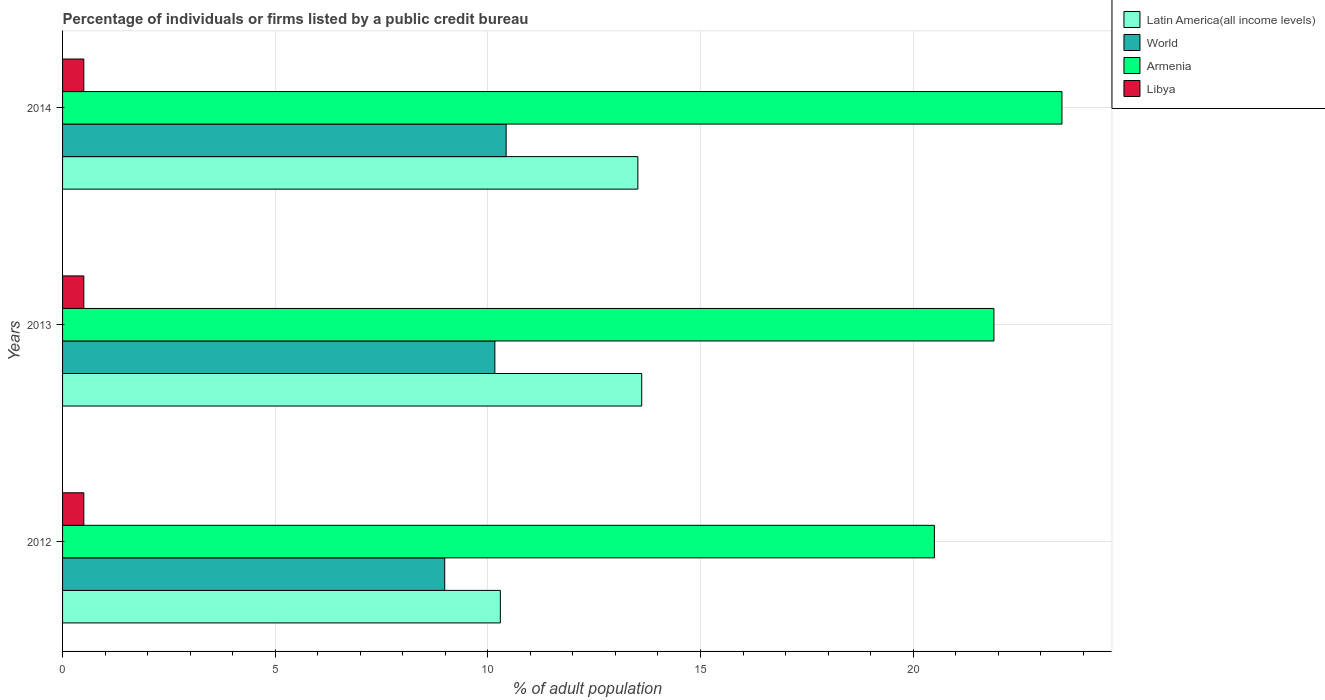How many different coloured bars are there?
Your answer should be compact. 4. Are the number of bars per tick equal to the number of legend labels?
Your answer should be compact. Yes. How many bars are there on the 2nd tick from the top?
Offer a terse response. 4. How many bars are there on the 3rd tick from the bottom?
Make the answer very short. 4. In how many cases, is the number of bars for a given year not equal to the number of legend labels?
Your answer should be very brief. 0. What is the percentage of population listed by a public credit bureau in World in 2014?
Keep it short and to the point. 10.43. Across all years, what is the maximum percentage of population listed by a public credit bureau in Latin America(all income levels)?
Make the answer very short. 13.62. Across all years, what is the minimum percentage of population listed by a public credit bureau in Libya?
Keep it short and to the point. 0.5. What is the total percentage of population listed by a public credit bureau in World in the graph?
Ensure brevity in your answer.  29.58. What is the difference between the percentage of population listed by a public credit bureau in Armenia in 2012 and that in 2013?
Make the answer very short. -1.4. What is the difference between the percentage of population listed by a public credit bureau in Armenia in 2013 and the percentage of population listed by a public credit bureau in Libya in 2012?
Give a very brief answer. 21.4. What is the average percentage of population listed by a public credit bureau in World per year?
Offer a very short reply. 9.86. In the year 2014, what is the difference between the percentage of population listed by a public credit bureau in Libya and percentage of population listed by a public credit bureau in Latin America(all income levels)?
Give a very brief answer. -13.03. What is the ratio of the percentage of population listed by a public credit bureau in Armenia in 2012 to that in 2014?
Ensure brevity in your answer.  0.87. What is the difference between the highest and the second highest percentage of population listed by a public credit bureau in Latin America(all income levels)?
Provide a short and direct response. 0.09. What is the difference between the highest and the lowest percentage of population listed by a public credit bureau in Armenia?
Make the answer very short. 3. Is the sum of the percentage of population listed by a public credit bureau in Libya in 2012 and 2014 greater than the maximum percentage of population listed by a public credit bureau in Latin America(all income levels) across all years?
Provide a short and direct response. No. Is it the case that in every year, the sum of the percentage of population listed by a public credit bureau in Latin America(all income levels) and percentage of population listed by a public credit bureau in World is greater than the sum of percentage of population listed by a public credit bureau in Libya and percentage of population listed by a public credit bureau in Armenia?
Make the answer very short. No. What does the 4th bar from the top in 2014 represents?
Make the answer very short. Latin America(all income levels). What does the 1st bar from the bottom in 2012 represents?
Make the answer very short. Latin America(all income levels). How many bars are there?
Your answer should be very brief. 12. How many years are there in the graph?
Make the answer very short. 3. What is the difference between two consecutive major ticks on the X-axis?
Ensure brevity in your answer.  5. Does the graph contain grids?
Provide a short and direct response. Yes. What is the title of the graph?
Offer a terse response. Percentage of individuals or firms listed by a public credit bureau. Does "Sao Tome and Principe" appear as one of the legend labels in the graph?
Your answer should be compact. No. What is the label or title of the X-axis?
Provide a succinct answer. % of adult population. What is the % of adult population of Latin America(all income levels) in 2012?
Keep it short and to the point. 10.29. What is the % of adult population of World in 2012?
Keep it short and to the point. 8.99. What is the % of adult population of Armenia in 2012?
Your response must be concise. 20.5. What is the % of adult population of Libya in 2012?
Ensure brevity in your answer.  0.5. What is the % of adult population in Latin America(all income levels) in 2013?
Offer a terse response. 13.62. What is the % of adult population in World in 2013?
Ensure brevity in your answer.  10.17. What is the % of adult population in Armenia in 2013?
Your answer should be very brief. 21.9. What is the % of adult population of Latin America(all income levels) in 2014?
Keep it short and to the point. 13.53. What is the % of adult population in World in 2014?
Offer a terse response. 10.43. What is the % of adult population in Armenia in 2014?
Your answer should be very brief. 23.5. Across all years, what is the maximum % of adult population in Latin America(all income levels)?
Ensure brevity in your answer.  13.62. Across all years, what is the maximum % of adult population in World?
Offer a terse response. 10.43. Across all years, what is the maximum % of adult population of Armenia?
Give a very brief answer. 23.5. Across all years, what is the minimum % of adult population in Latin America(all income levels)?
Provide a succinct answer. 10.29. Across all years, what is the minimum % of adult population in World?
Offer a terse response. 8.99. What is the total % of adult population of Latin America(all income levels) in the graph?
Ensure brevity in your answer.  37.44. What is the total % of adult population of World in the graph?
Give a very brief answer. 29.58. What is the total % of adult population in Armenia in the graph?
Offer a very short reply. 65.9. What is the difference between the % of adult population of Latin America(all income levels) in 2012 and that in 2013?
Give a very brief answer. -3.32. What is the difference between the % of adult population of World in 2012 and that in 2013?
Provide a succinct answer. -1.18. What is the difference between the % of adult population of Armenia in 2012 and that in 2013?
Your answer should be compact. -1.4. What is the difference between the % of adult population of Latin America(all income levels) in 2012 and that in 2014?
Make the answer very short. -3.23. What is the difference between the % of adult population in World in 2012 and that in 2014?
Give a very brief answer. -1.44. What is the difference between the % of adult population in Latin America(all income levels) in 2013 and that in 2014?
Provide a short and direct response. 0.09. What is the difference between the % of adult population of World in 2013 and that in 2014?
Your answer should be compact. -0.27. What is the difference between the % of adult population of Latin America(all income levels) in 2012 and the % of adult population of World in 2013?
Your answer should be very brief. 0.13. What is the difference between the % of adult population in Latin America(all income levels) in 2012 and the % of adult population in Armenia in 2013?
Your response must be concise. -11.61. What is the difference between the % of adult population in Latin America(all income levels) in 2012 and the % of adult population in Libya in 2013?
Keep it short and to the point. 9.79. What is the difference between the % of adult population in World in 2012 and the % of adult population in Armenia in 2013?
Ensure brevity in your answer.  -12.91. What is the difference between the % of adult population of World in 2012 and the % of adult population of Libya in 2013?
Provide a short and direct response. 8.49. What is the difference between the % of adult population in Armenia in 2012 and the % of adult population in Libya in 2013?
Your answer should be compact. 20. What is the difference between the % of adult population in Latin America(all income levels) in 2012 and the % of adult population in World in 2014?
Provide a short and direct response. -0.14. What is the difference between the % of adult population in Latin America(all income levels) in 2012 and the % of adult population in Armenia in 2014?
Your response must be concise. -13.21. What is the difference between the % of adult population of Latin America(all income levels) in 2012 and the % of adult population of Libya in 2014?
Offer a terse response. 9.79. What is the difference between the % of adult population in World in 2012 and the % of adult population in Armenia in 2014?
Give a very brief answer. -14.51. What is the difference between the % of adult population in World in 2012 and the % of adult population in Libya in 2014?
Your response must be concise. 8.49. What is the difference between the % of adult population in Armenia in 2012 and the % of adult population in Libya in 2014?
Provide a short and direct response. 20. What is the difference between the % of adult population in Latin America(all income levels) in 2013 and the % of adult population in World in 2014?
Provide a succinct answer. 3.19. What is the difference between the % of adult population in Latin America(all income levels) in 2013 and the % of adult population in Armenia in 2014?
Your answer should be compact. -9.88. What is the difference between the % of adult population of Latin America(all income levels) in 2013 and the % of adult population of Libya in 2014?
Ensure brevity in your answer.  13.12. What is the difference between the % of adult population of World in 2013 and the % of adult population of Armenia in 2014?
Keep it short and to the point. -13.33. What is the difference between the % of adult population in World in 2013 and the % of adult population in Libya in 2014?
Ensure brevity in your answer.  9.67. What is the difference between the % of adult population of Armenia in 2013 and the % of adult population of Libya in 2014?
Your answer should be compact. 21.4. What is the average % of adult population in Latin America(all income levels) per year?
Ensure brevity in your answer.  12.48. What is the average % of adult population of World per year?
Offer a very short reply. 9.86. What is the average % of adult population of Armenia per year?
Provide a short and direct response. 21.97. What is the average % of adult population in Libya per year?
Your response must be concise. 0.5. In the year 2012, what is the difference between the % of adult population of Latin America(all income levels) and % of adult population of World?
Ensure brevity in your answer.  1.31. In the year 2012, what is the difference between the % of adult population of Latin America(all income levels) and % of adult population of Armenia?
Keep it short and to the point. -10.21. In the year 2012, what is the difference between the % of adult population in Latin America(all income levels) and % of adult population in Libya?
Provide a short and direct response. 9.79. In the year 2012, what is the difference between the % of adult population in World and % of adult population in Armenia?
Provide a succinct answer. -11.51. In the year 2012, what is the difference between the % of adult population in World and % of adult population in Libya?
Your answer should be very brief. 8.49. In the year 2012, what is the difference between the % of adult population of Armenia and % of adult population of Libya?
Give a very brief answer. 20. In the year 2013, what is the difference between the % of adult population in Latin America(all income levels) and % of adult population in World?
Provide a succinct answer. 3.45. In the year 2013, what is the difference between the % of adult population of Latin America(all income levels) and % of adult population of Armenia?
Your answer should be compact. -8.28. In the year 2013, what is the difference between the % of adult population of Latin America(all income levels) and % of adult population of Libya?
Provide a succinct answer. 13.12. In the year 2013, what is the difference between the % of adult population in World and % of adult population in Armenia?
Make the answer very short. -11.73. In the year 2013, what is the difference between the % of adult population in World and % of adult population in Libya?
Provide a short and direct response. 9.67. In the year 2013, what is the difference between the % of adult population in Armenia and % of adult population in Libya?
Offer a very short reply. 21.4. In the year 2014, what is the difference between the % of adult population in Latin America(all income levels) and % of adult population in World?
Ensure brevity in your answer.  3.1. In the year 2014, what is the difference between the % of adult population in Latin America(all income levels) and % of adult population in Armenia?
Ensure brevity in your answer.  -9.97. In the year 2014, what is the difference between the % of adult population of Latin America(all income levels) and % of adult population of Libya?
Give a very brief answer. 13.03. In the year 2014, what is the difference between the % of adult population of World and % of adult population of Armenia?
Your answer should be very brief. -13.07. In the year 2014, what is the difference between the % of adult population in World and % of adult population in Libya?
Offer a very short reply. 9.93. In the year 2014, what is the difference between the % of adult population in Armenia and % of adult population in Libya?
Make the answer very short. 23. What is the ratio of the % of adult population of Latin America(all income levels) in 2012 to that in 2013?
Give a very brief answer. 0.76. What is the ratio of the % of adult population in World in 2012 to that in 2013?
Your answer should be very brief. 0.88. What is the ratio of the % of adult population in Armenia in 2012 to that in 2013?
Make the answer very short. 0.94. What is the ratio of the % of adult population in Libya in 2012 to that in 2013?
Provide a short and direct response. 1. What is the ratio of the % of adult population in Latin America(all income levels) in 2012 to that in 2014?
Ensure brevity in your answer.  0.76. What is the ratio of the % of adult population in World in 2012 to that in 2014?
Your response must be concise. 0.86. What is the ratio of the % of adult population of Armenia in 2012 to that in 2014?
Give a very brief answer. 0.87. What is the ratio of the % of adult population of World in 2013 to that in 2014?
Offer a very short reply. 0.97. What is the ratio of the % of adult population in Armenia in 2013 to that in 2014?
Provide a succinct answer. 0.93. What is the difference between the highest and the second highest % of adult population of Latin America(all income levels)?
Offer a terse response. 0.09. What is the difference between the highest and the second highest % of adult population in World?
Offer a very short reply. 0.27. What is the difference between the highest and the second highest % of adult population of Libya?
Keep it short and to the point. 0. What is the difference between the highest and the lowest % of adult population of Latin America(all income levels)?
Offer a very short reply. 3.32. What is the difference between the highest and the lowest % of adult population of World?
Your response must be concise. 1.44. What is the difference between the highest and the lowest % of adult population of Armenia?
Your answer should be compact. 3. 